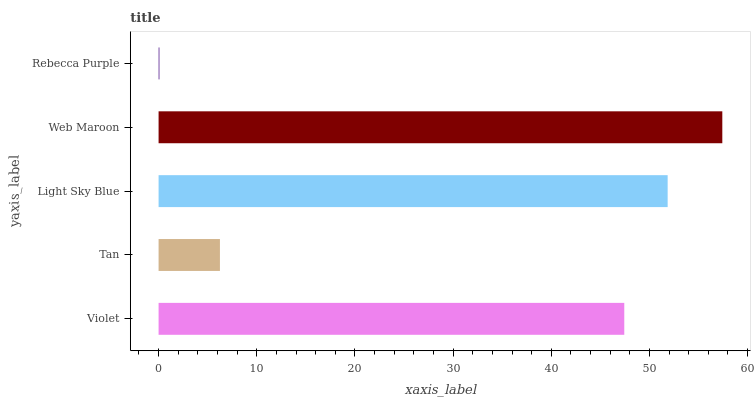Is Rebecca Purple the minimum?
Answer yes or no. Yes. Is Web Maroon the maximum?
Answer yes or no. Yes. Is Tan the minimum?
Answer yes or no. No. Is Tan the maximum?
Answer yes or no. No. Is Violet greater than Tan?
Answer yes or no. Yes. Is Tan less than Violet?
Answer yes or no. Yes. Is Tan greater than Violet?
Answer yes or no. No. Is Violet less than Tan?
Answer yes or no. No. Is Violet the high median?
Answer yes or no. Yes. Is Violet the low median?
Answer yes or no. Yes. Is Tan the high median?
Answer yes or no. No. Is Web Maroon the low median?
Answer yes or no. No. 